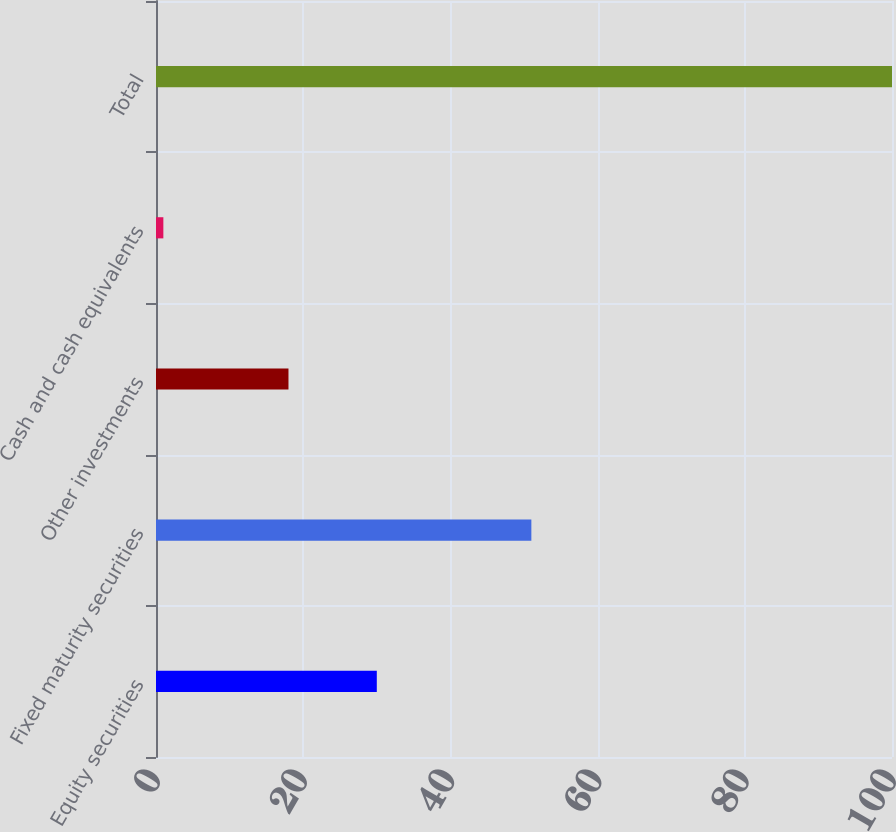Convert chart. <chart><loc_0><loc_0><loc_500><loc_500><bar_chart><fcel>Equity securities<fcel>Fixed maturity securities<fcel>Other investments<fcel>Cash and cash equivalents<fcel>Total<nl><fcel>30<fcel>51<fcel>18<fcel>1<fcel>100<nl></chart> 